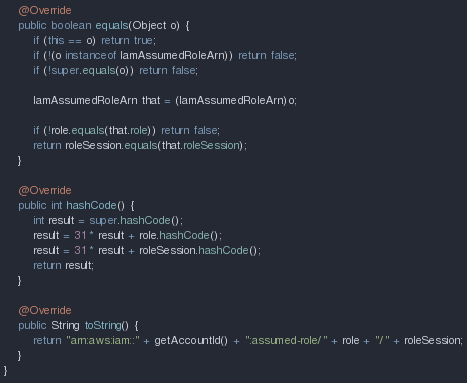Convert code to text. <code><loc_0><loc_0><loc_500><loc_500><_Java_>
    @Override
    public boolean equals(Object o) {
        if (this == o) return true;
        if (!(o instanceof IamAssumedRoleArn)) return false;
        if (!super.equals(o)) return false;

        IamAssumedRoleArn that = (IamAssumedRoleArn)o;

        if (!role.equals(that.role)) return false;
        return roleSession.equals(that.roleSession);
    }

    @Override
    public int hashCode() {
        int result = super.hashCode();
        result = 31 * result + role.hashCode();
        result = 31 * result + roleSession.hashCode();
        return result;
    }

    @Override
    public String toString() {
        return "arn:aws:iam::" + getAccountId() + ":assumed-role/" + role + "/" + roleSession;
    }
}
</code> 